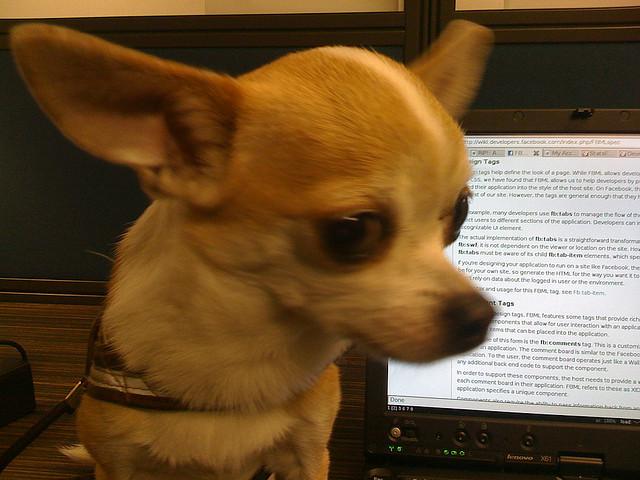Is the computer a laptop model?
Give a very brief answer. Yes. What kind of dog is this?
Short answer required. Chihuahua. Is the dog using the computer?
Concise answer only. No. 